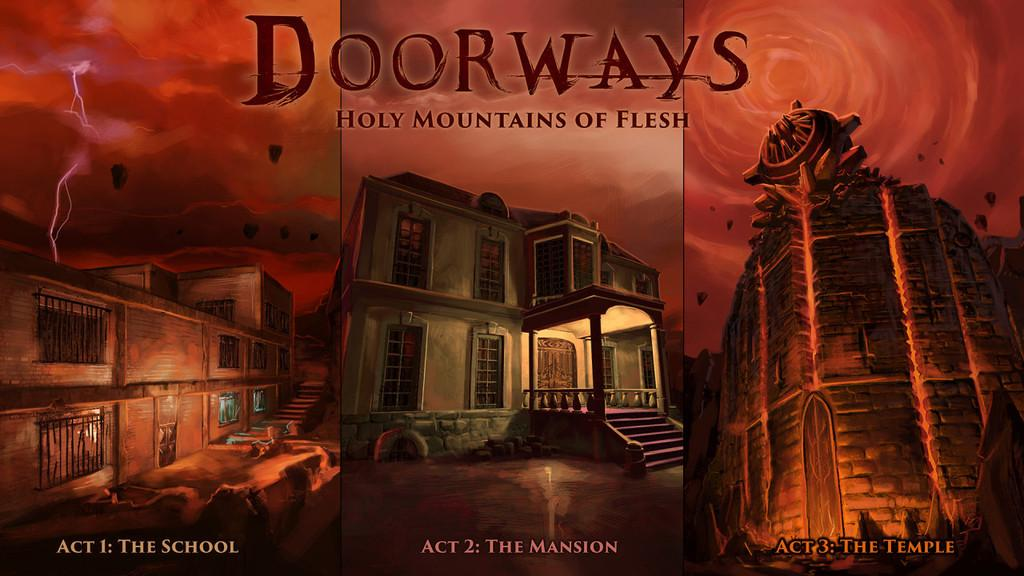<image>
Share a concise interpretation of the image provided. A Three Act series, Dorways, all laid out side by side. 